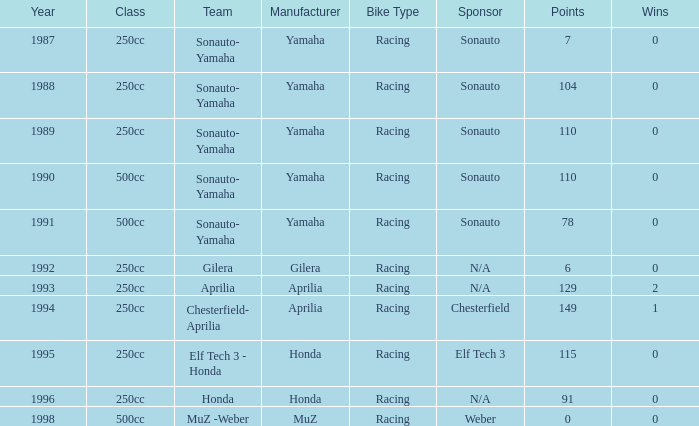How many wins did the team, which had more than 110 points, have in 1989? None. 